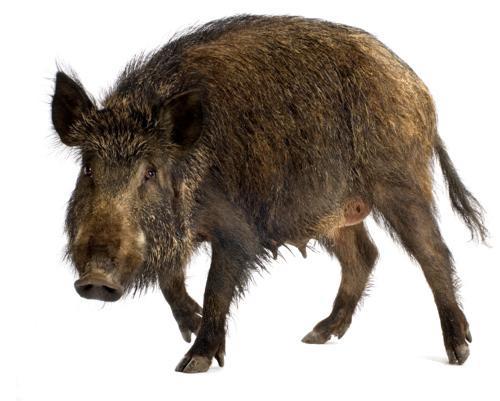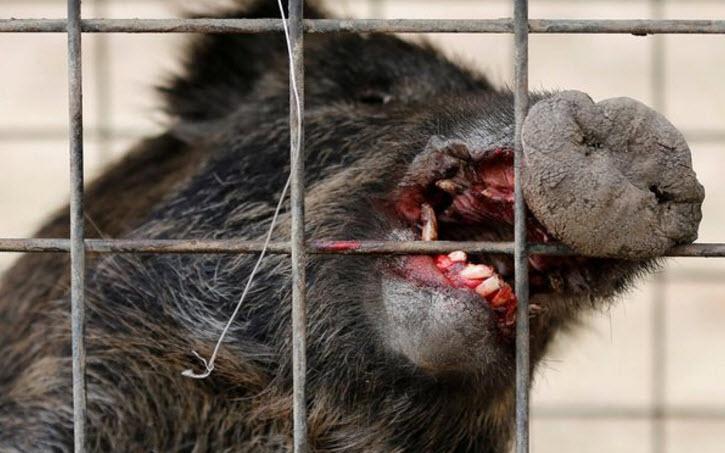The first image is the image on the left, the second image is the image on the right. Given the left and right images, does the statement "There is more than one animal species in the image." hold true? Answer yes or no. No. The first image is the image on the left, the second image is the image on the right. Assess this claim about the two images: "The left image contains exactly one wild boar.". Correct or not? Answer yes or no. Yes. 